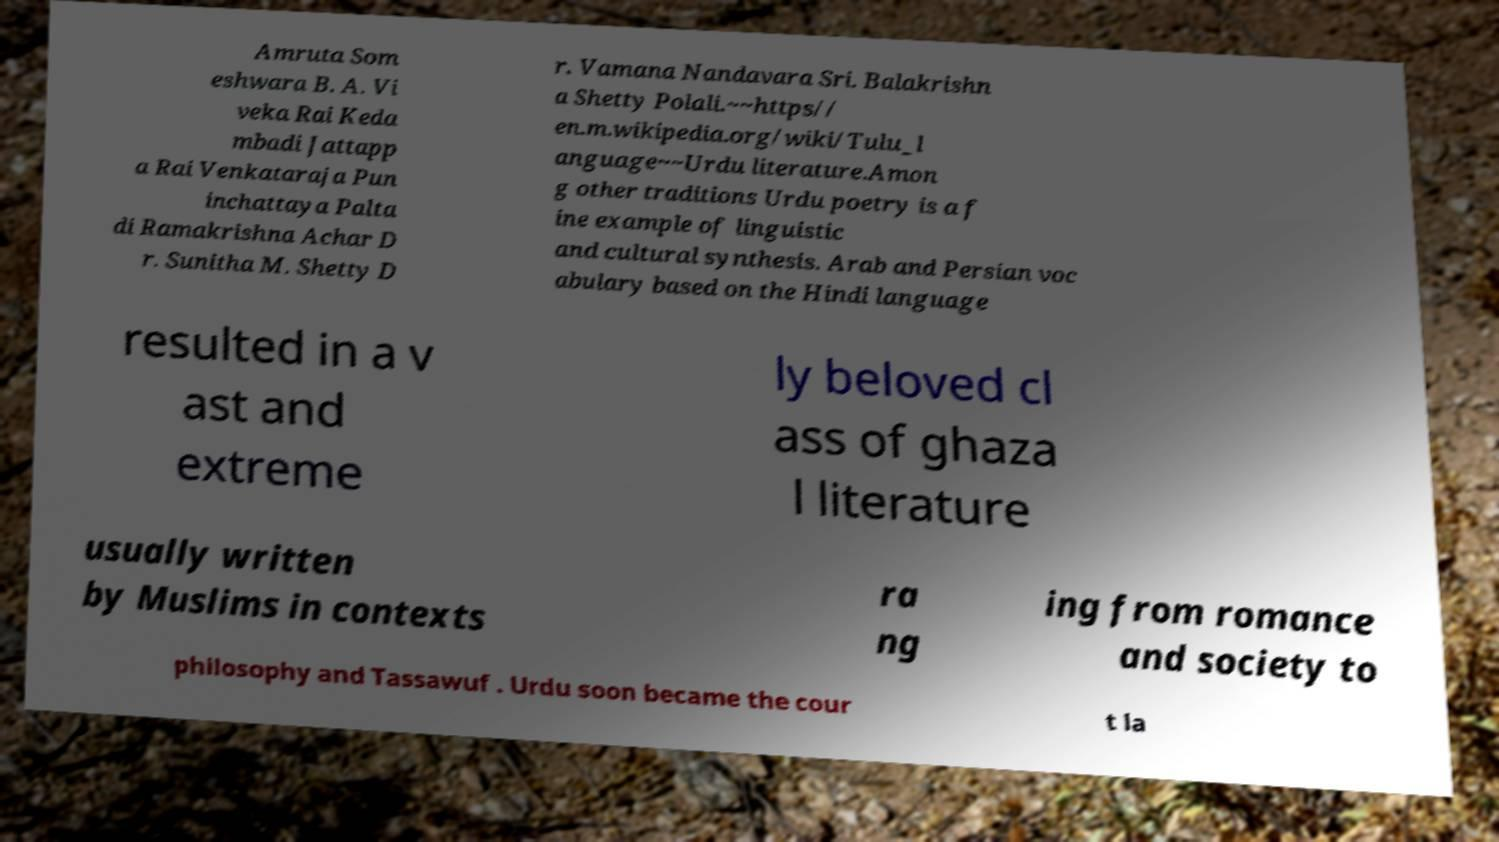Please identify and transcribe the text found in this image. Amruta Som eshwara B. A. Vi veka Rai Keda mbadi Jattapp a Rai Venkataraja Pun inchattaya Palta di Ramakrishna Achar D r. Sunitha M. Shetty D r. Vamana Nandavara Sri. Balakrishn a Shetty Polali.~~https// en.m.wikipedia.org/wiki/Tulu_l anguage~~Urdu literature.Amon g other traditions Urdu poetry is a f ine example of linguistic and cultural synthesis. Arab and Persian voc abulary based on the Hindi language resulted in a v ast and extreme ly beloved cl ass of ghaza l literature usually written by Muslims in contexts ra ng ing from romance and society to philosophy and Tassawuf . Urdu soon became the cour t la 